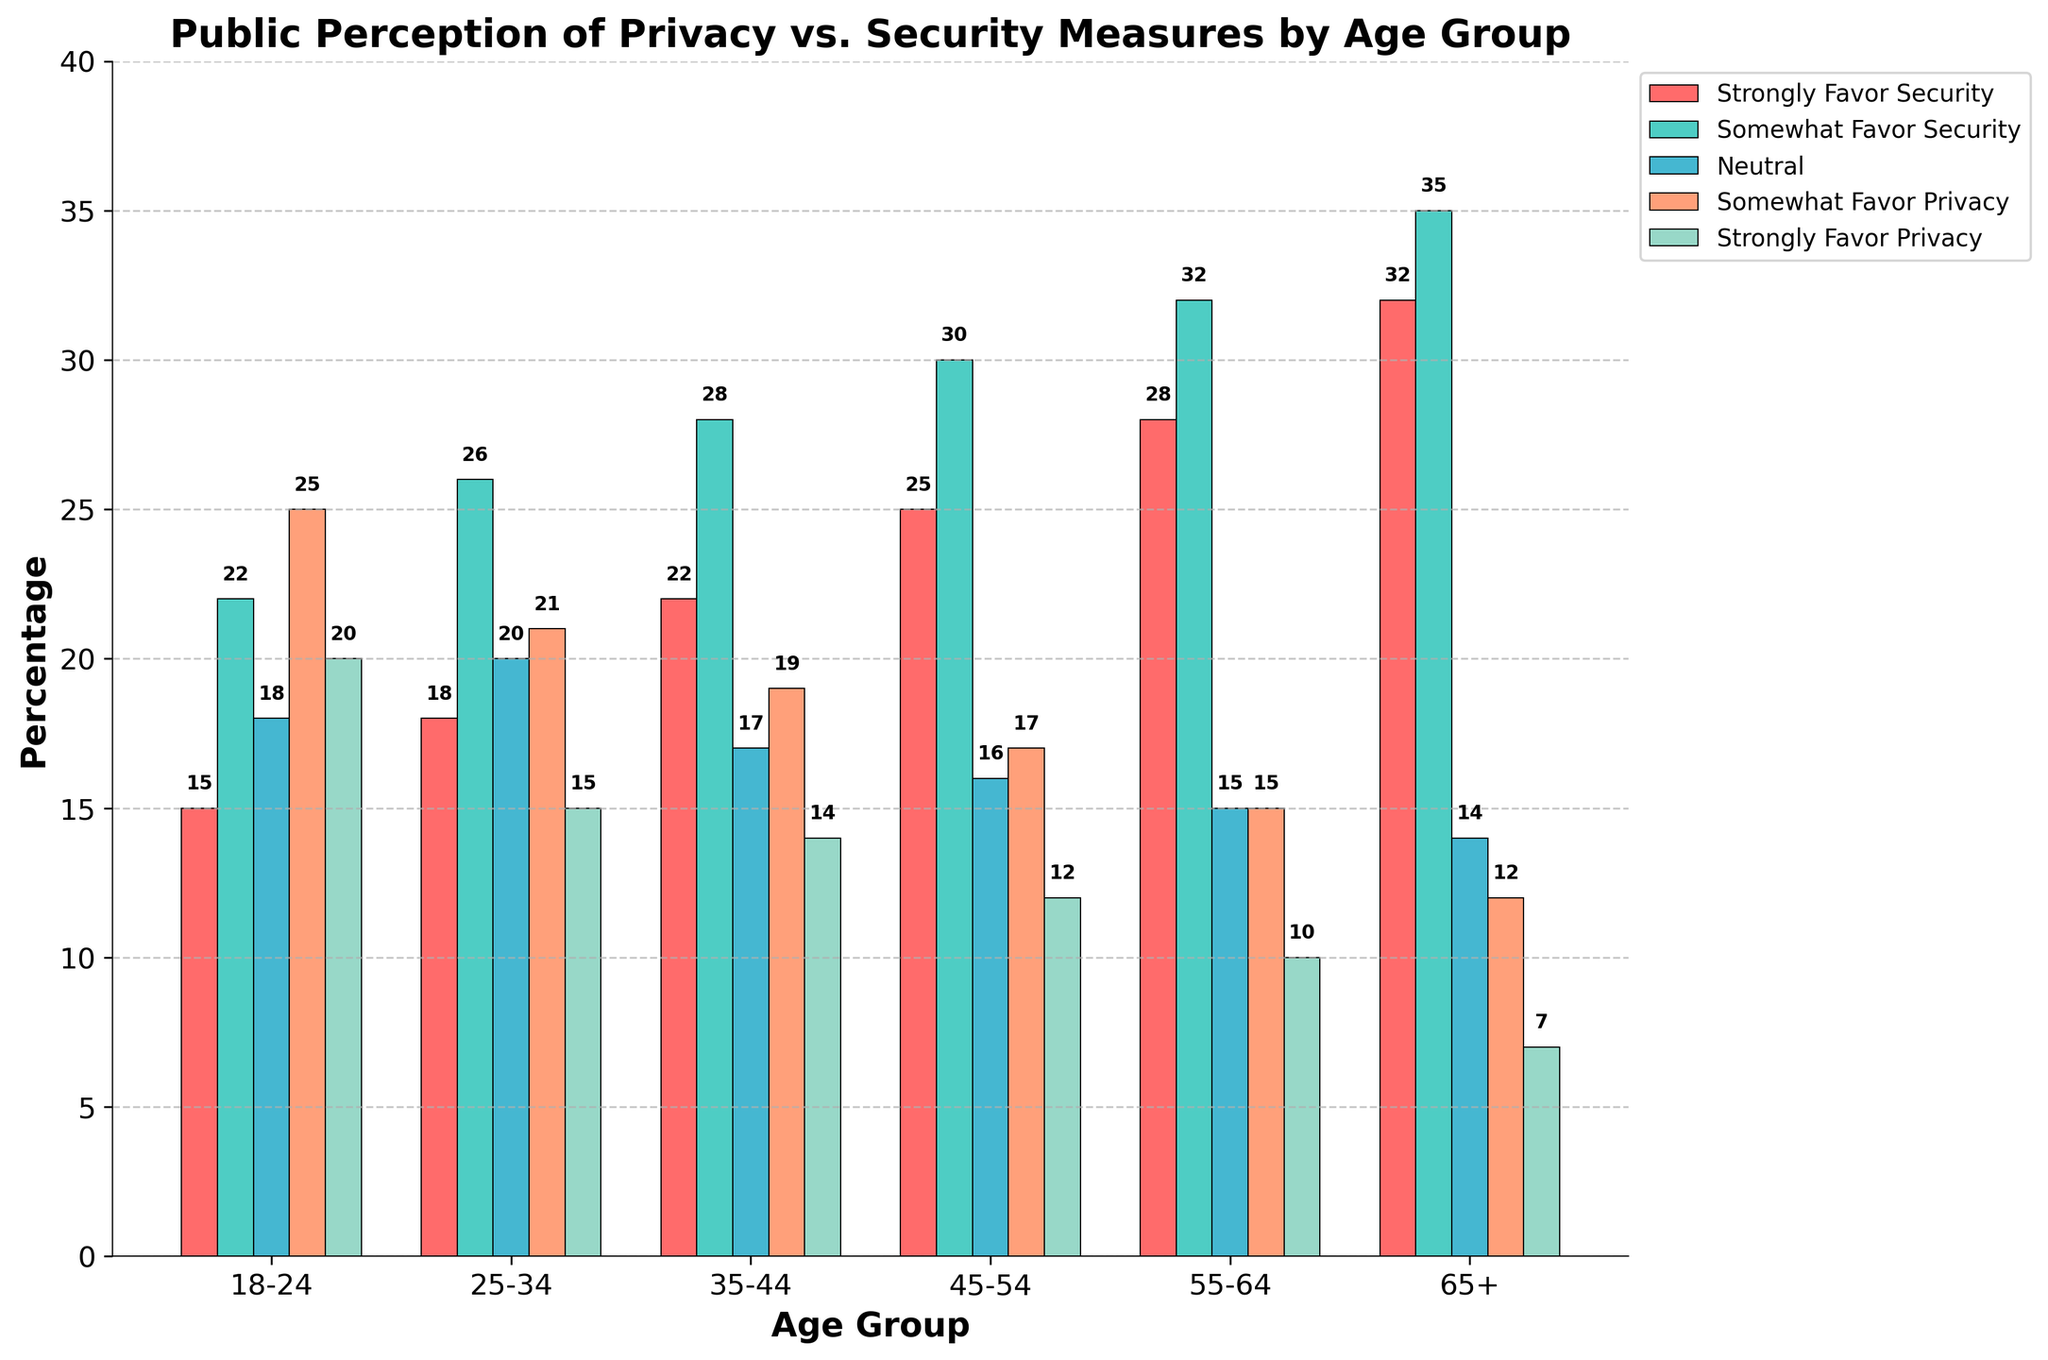What age group has the highest percentage of people who strongly favor security? The bar for "Strongly Favor Security" is highest for the "65+" age group.
Answer: 65+ Which age group has a greater percentage of people who are neutral, 18-24 or 55-64? The bar for "Neutral" is higher for the age group 18-24 at around 18, while 55-64 is lower at around 15.
Answer: 18-24 What is the combined percentage of people from the 25-34 age group who are either neutral or somewhat favor privacy? The percentage for "Neutral" in the 25-34 age group is 20, and for "Somewhat Favor Privacy" is 21. The sum is 20 + 21 = 41.
Answer: 41 Which age group has the smallest percentage of people who strongly favor privacy? The bar for "Strongly Favor Privacy" is shortest for the "65+" age group at about 7%.
Answer: 65+ How does the percentage of people who somewhat favor security compare between the 35-44 and 55-64 age groups? The bar for "Somewhat Favor Security" is around 28 for the 35-44 age group and 32 for the 55-64 age group. Therefore, 55-64 is higher.
Answer: 55-64 What is the difference between the percentage of people who strongly favor security and those who strongly favor privacy in the 45-54 age group? The "Strongly Favor Security" percentage for the 45-54 age group is 25, and "Strongly Favor Privacy" is 12. The difference is 25 - 12 = 13.
Answer: 13 What is the combined percentage of people who favor privacy (both strongly and somewhat) in the 18-24 age group? The percentage of "Strongly Favor Privacy" in the 18-24 age group is 20, and "Somewhat Favor Privacy" is 25. The sum is 20 + 25 = 45.
Answer: 45 Is the percentage of people who somewhat favor security higher in the 55-64 age group compared to those who somewhat favor privacy in the same age group? The "Somewhat Favor Security" percentage for the 55-64 age group is 32, and "Somewhat Favor Privacy" is 15. 32 is higher than 15.
Answer: Yes 